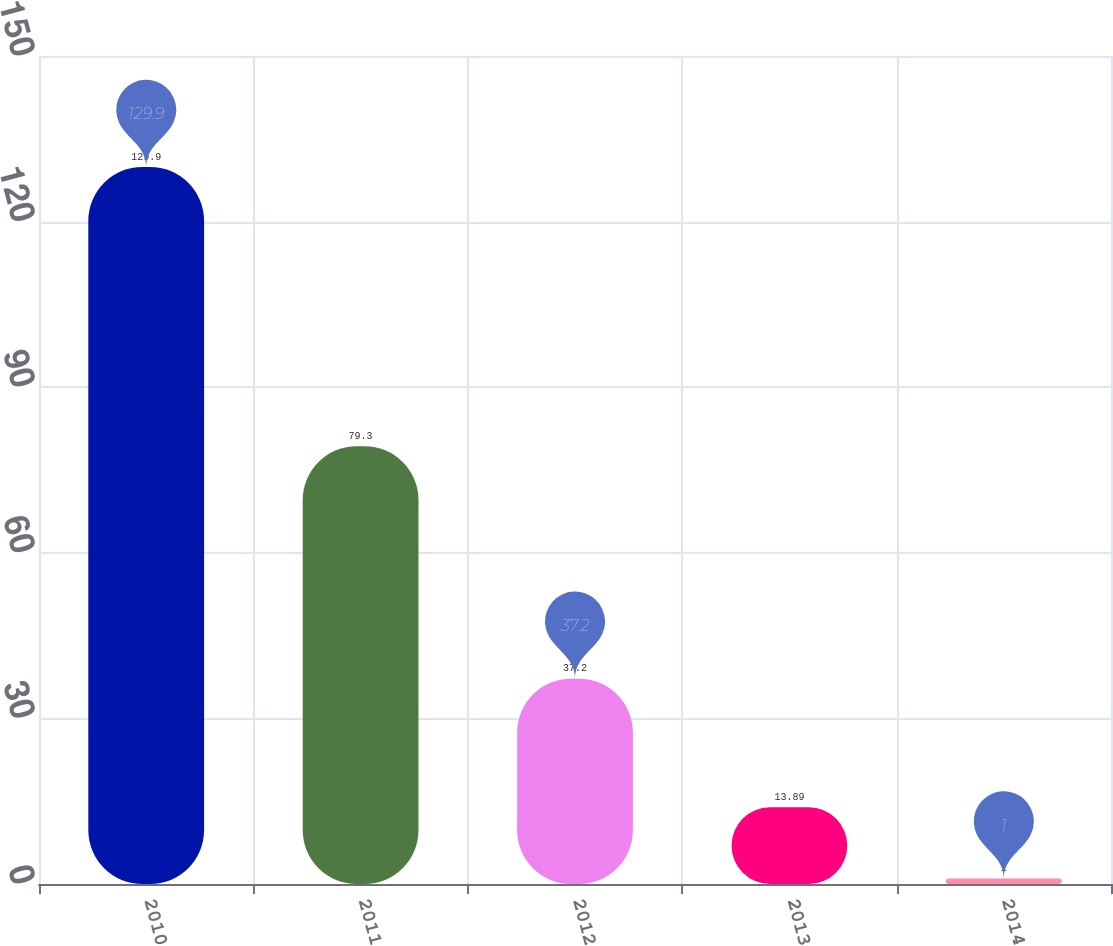Convert chart. <chart><loc_0><loc_0><loc_500><loc_500><bar_chart><fcel>2010<fcel>2011<fcel>2012<fcel>2013<fcel>2014<nl><fcel>129.9<fcel>79.3<fcel>37.2<fcel>13.89<fcel>1<nl></chart> 